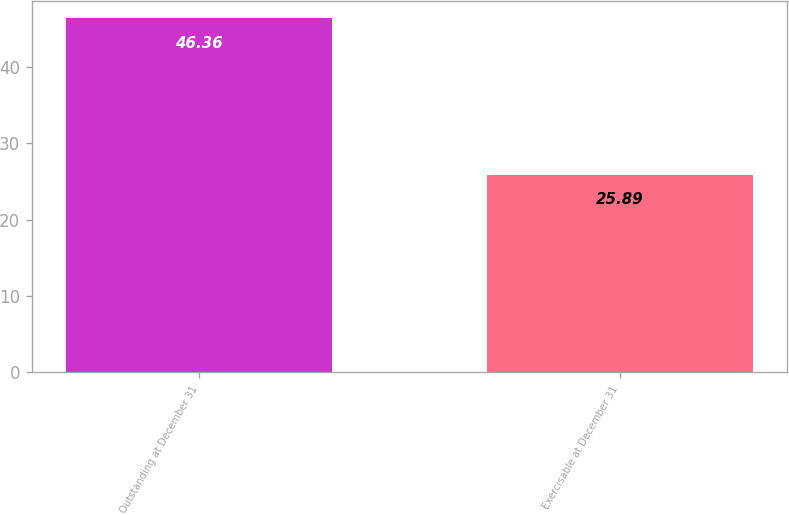<chart> <loc_0><loc_0><loc_500><loc_500><bar_chart><fcel>Outstanding at December 31<fcel>Exercisable at December 31<nl><fcel>46.36<fcel>25.89<nl></chart> 